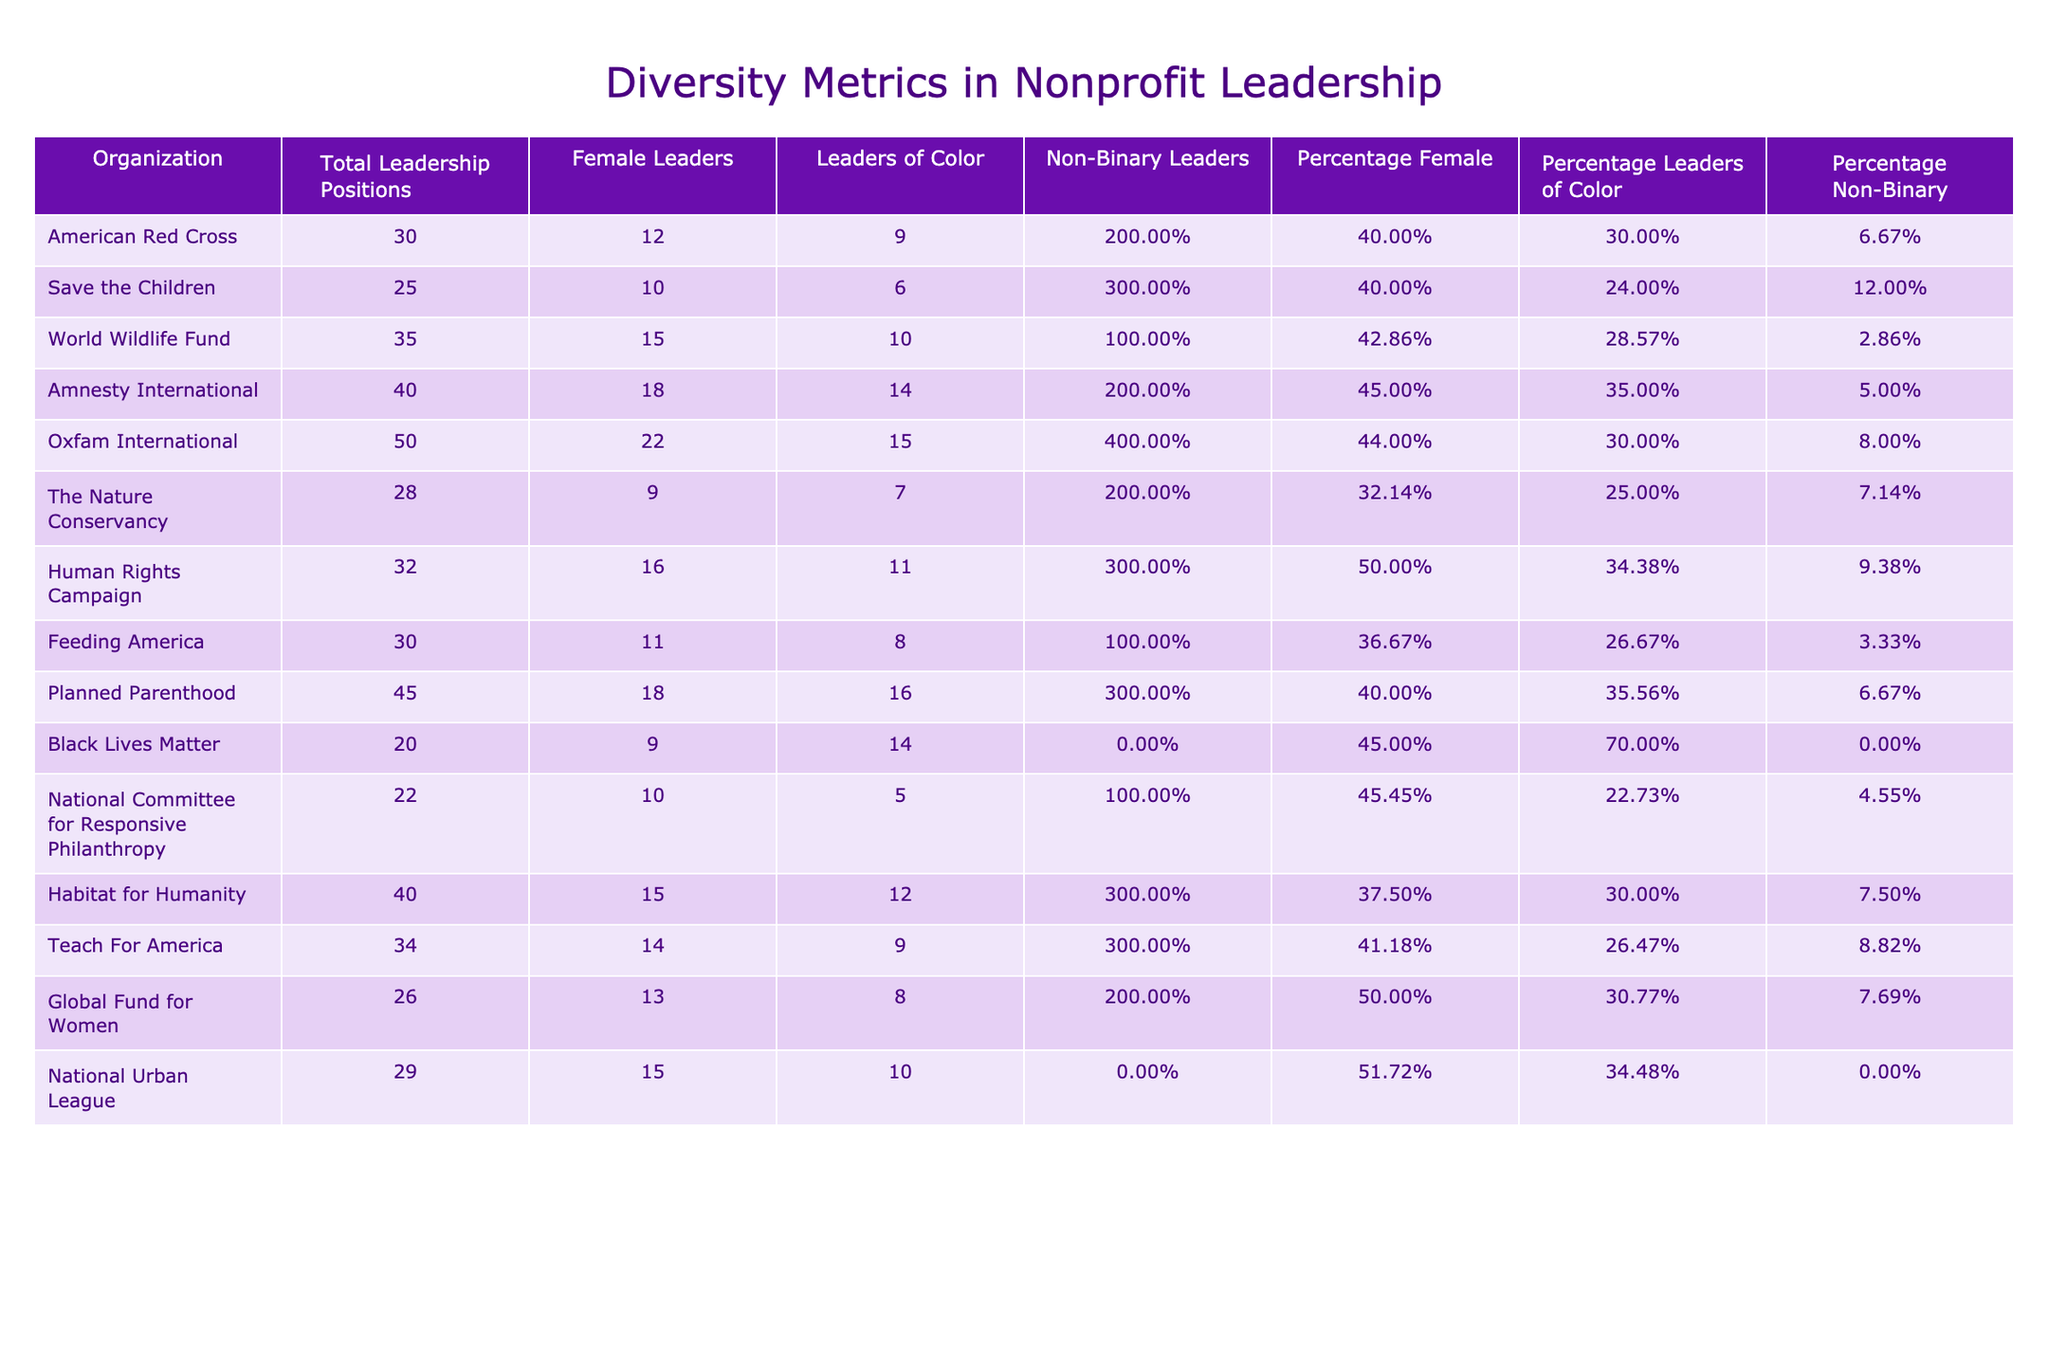What is the total number of leadership positions in Oxfam International? From the table, we can directly find the value in the "Total Leadership Positions" column for Oxfam International, which is 50.
Answer: 50 What percentage of leaders at Amnesty International are female? Referring to the percentage column for Amnesty International, we see that 45% of leaders are female.
Answer: 45% Which organization has the highest percentage of leaders of color? By examining the "Percentage Leaders of Color" column, Black Lives Matter has the highest value at 70%.
Answer: 70% What is the average percentage of non-binary leaders across all organizations listed? To find the average, we sum up all the percentages in the “Percentage Non-Binary” column: (6.67 + 12 + 2.86 + 5 + 8 + 7.14 + 9.38 + 3.33 + 6.67 + 0 + 4.55 + 7.5 + 8.82 + 7.69 + 0) = 78.53. Dividing by the total number of organizations (14) gives: 78.53/14 = 5.59%.
Answer: 5.59% Is it true that all organizations have at least 20 total leadership positions? By checking the "Total Leadership Positions" column, we find that Black Lives Matter has only 20 total leadership positions. Thus not all organizations exceed this count.
Answer: No Which organization has the least percentage of female leaders? By looking at the “Percentage Female” column, The Nature Conservancy has the lowest percentage at 32.14%.
Answer: 32.14% How many organizations have more than 30% of their leadership positions held by leaders of color? By scanning the "Percentage Leaders of Color" column, the organizations with more than 30% are Black Lives Matter (70%), Amnesty International (35%), Planned Parenthood (35.56%), Human Rights Campaign (34.38%), and National Urban League (34.48%). This totals 5 organizations.
Answer: 5 What is the difference in the number of female leaders between Save the Children and the World Wildlife Fund? For Save the Children, the number of female leaders is 10 and for the World Wildlife Fund, it is 15. The difference is calculated as 15 - 10 = 5.
Answer: 5 How many total leadership positions are held by non-binary leaders across all organizations? By adding the values in the "Non-Binary Leaders" column, the total is (2 + 3 + 1 + 2 + 4 + 2 + 3 + 1 + 3 + 0 + 1 + 3 + 2 + 0) = 23.
Answer: 23 